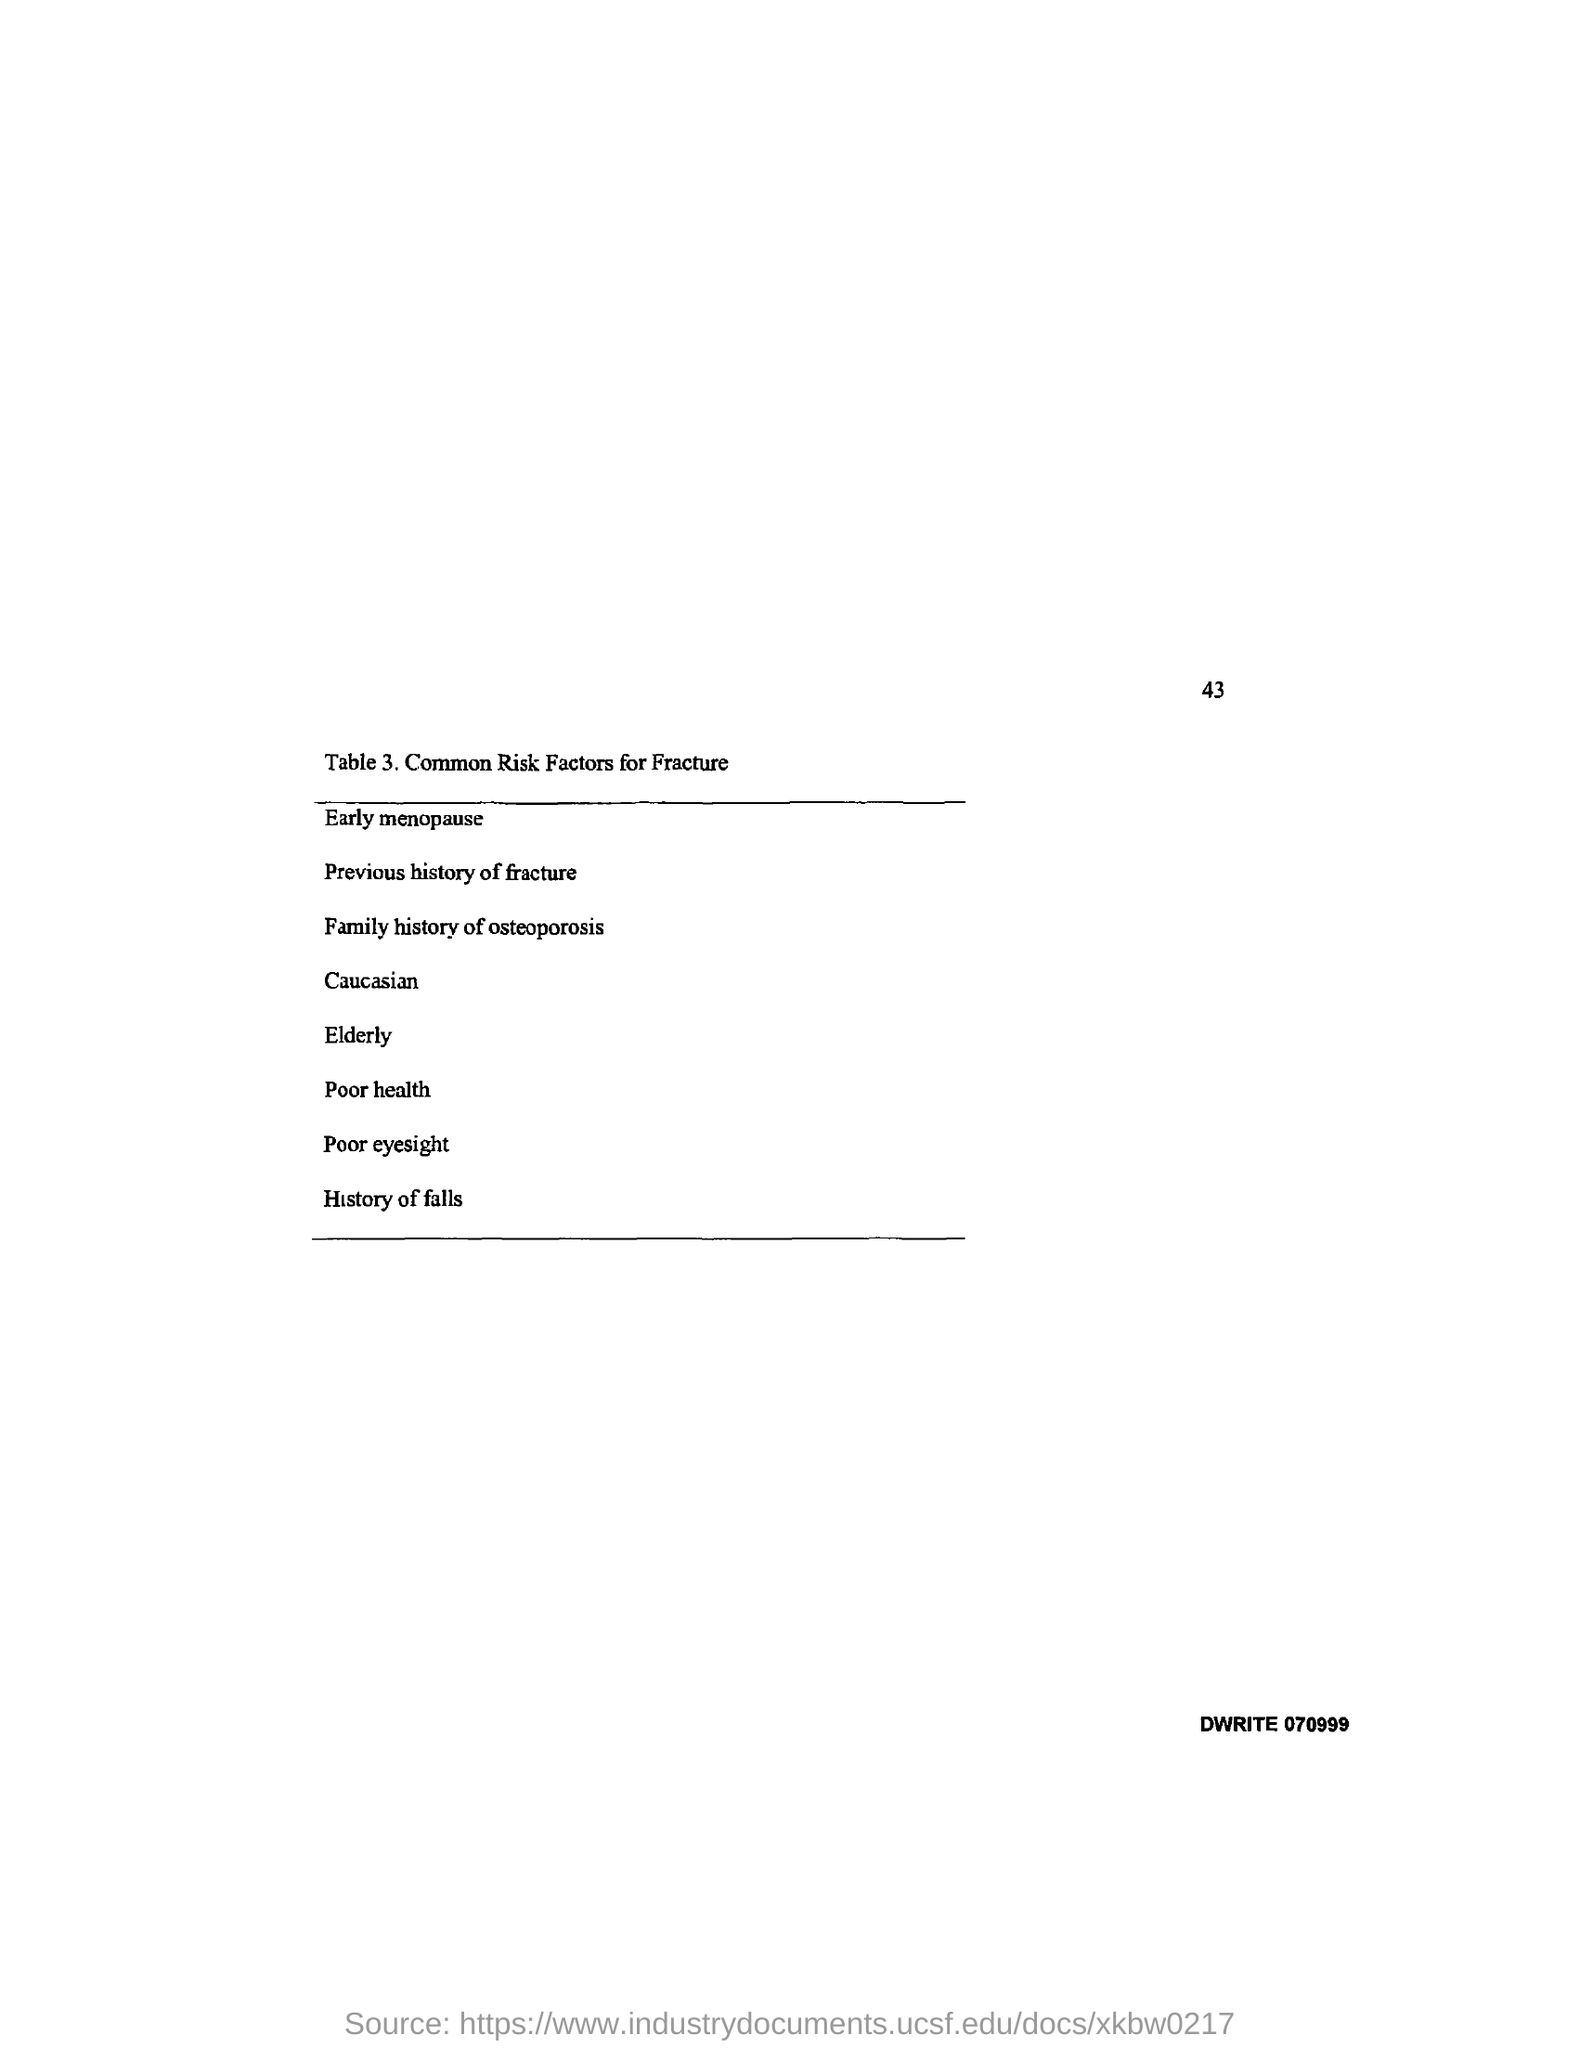What is the page no mentioned in this document?
Offer a very short reply. 43. What does Table 3. in this document describe?
Give a very brief answer. Common Risk Factors for Fracture. What is the first risk factor for fracture mentioned in Table 3.?
Provide a short and direct response. Early menopause. What is the last risk factor for fracture mentioned in Table 3.?
Offer a terse response. History of falls. 